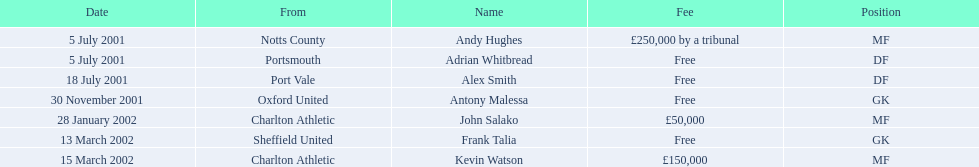List all the players names Andy Hughes, Adrian Whitbread, Alex Smith, Antony Malessa, John Salako, Frank Talia, Kevin Watson. Of these who is kevin watson Kevin Watson. To what transfer fee entry does kevin correspond to? £150,000. 